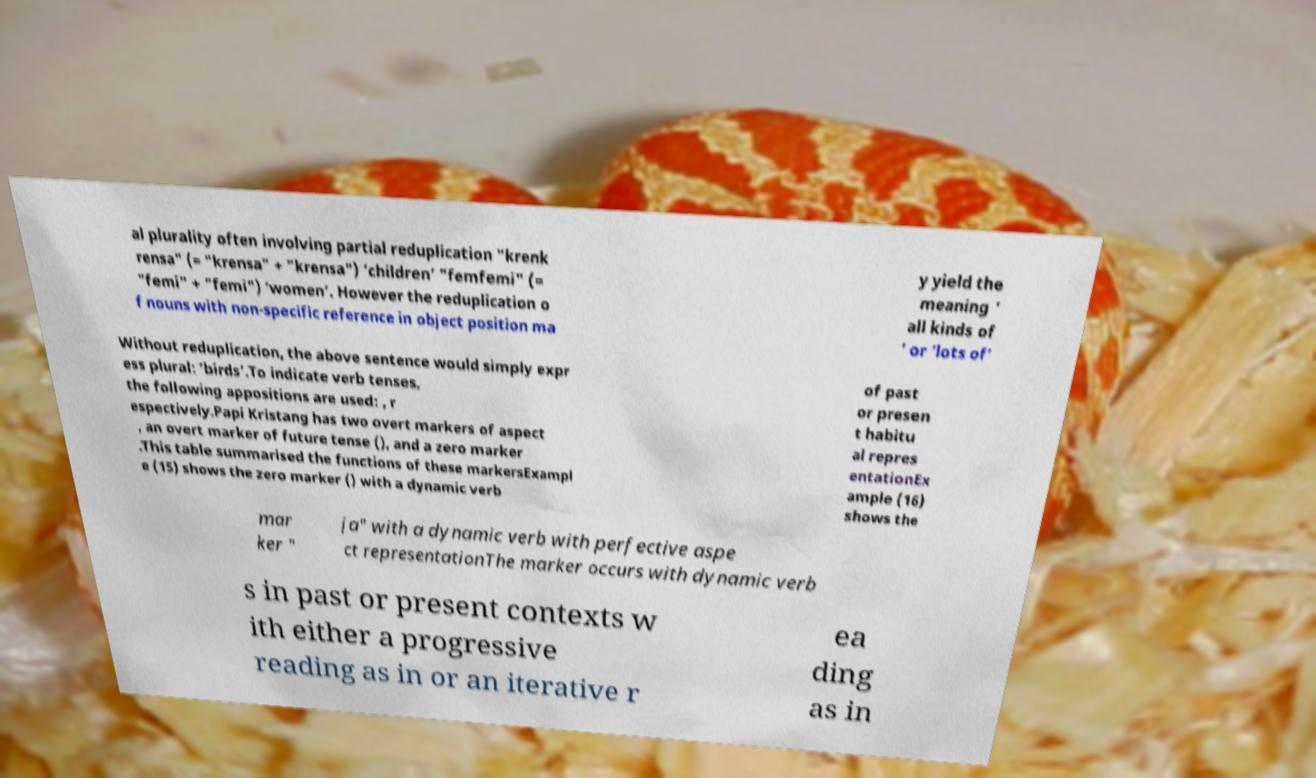What messages or text are displayed in this image? I need them in a readable, typed format. al plurality often involving partial reduplication "krenk rensa" (= "krensa" + "krensa") ‘children’ "femfemi" (= "femi" + "femi") ‘women’. However the reduplication o f nouns with non-specific reference in object position ma y yield the meaning ‘ all kinds of ’ or ‘lots of’ Without reduplication, the above sentence would simply expr ess plural: ‘birds’.To indicate verb tenses, the following appositions are used: , r espectively.Papi Kristang has two overt markers of aspect , an overt marker of future tense (), and a zero marker .This table summarised the functions of these markersExampl e (15) shows the zero marker () with a dynamic verb of past or presen t habitu al repres entationEx ample (16) shows the mar ker " ja" with a dynamic verb with perfective aspe ct representationThe marker occurs with dynamic verb s in past or present contexts w ith either a progressive reading as in or an iterative r ea ding as in 